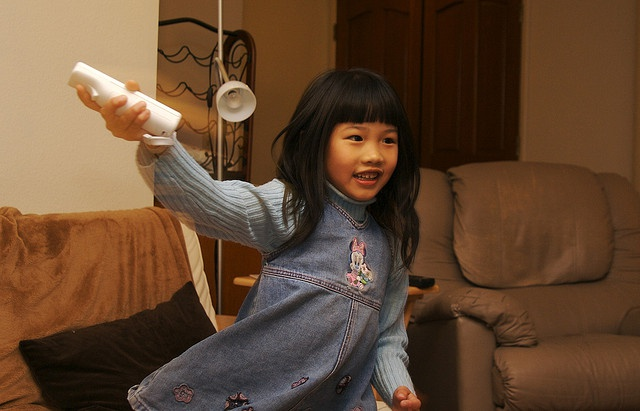Describe the objects in this image and their specific colors. I can see people in tan, black, gray, maroon, and brown tones, chair in tan, maroon, black, and brown tones, couch in tan, brown, black, and maroon tones, and remote in tan, ivory, and gray tones in this image. 